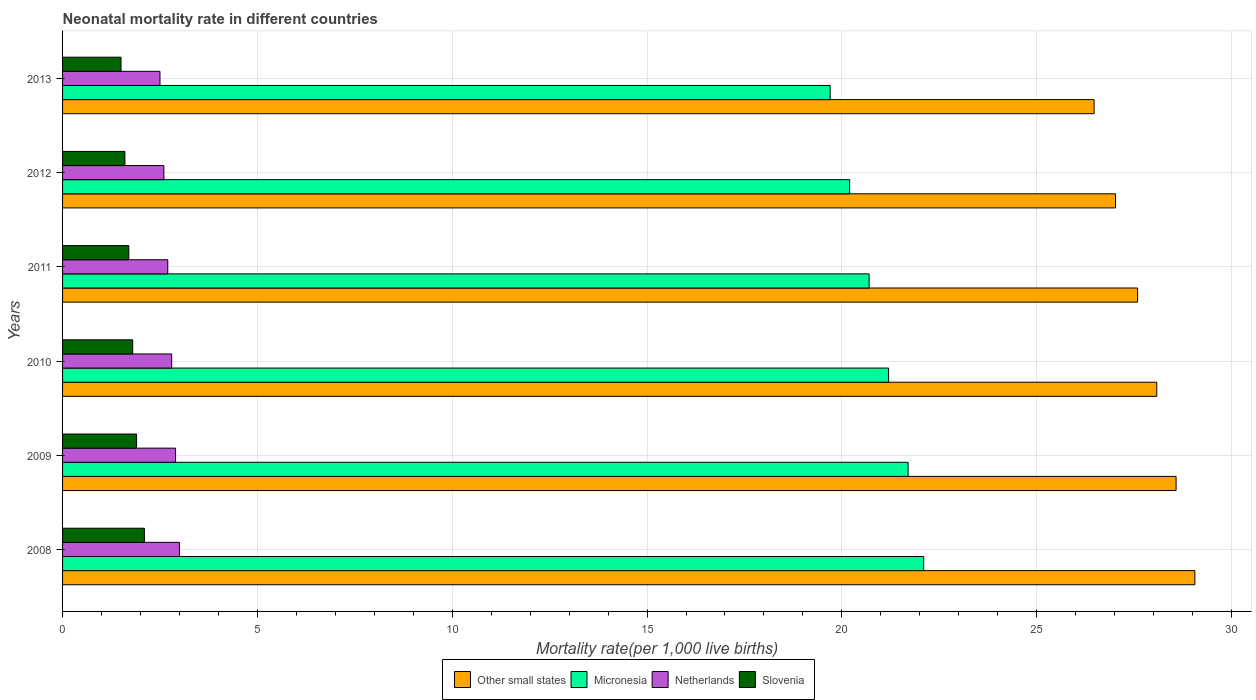How many different coloured bars are there?
Offer a very short reply. 4. Are the number of bars on each tick of the Y-axis equal?
Provide a succinct answer. Yes. In how many cases, is the number of bars for a given year not equal to the number of legend labels?
Give a very brief answer. 0. What is the neonatal mortality rate in Micronesia in 2009?
Your response must be concise. 21.7. Across all years, what is the minimum neonatal mortality rate in Netherlands?
Offer a very short reply. 2.5. In which year was the neonatal mortality rate in Slovenia maximum?
Your answer should be very brief. 2008. What is the difference between the neonatal mortality rate in Other small states in 2011 and the neonatal mortality rate in Slovenia in 2013?
Offer a terse response. 26.09. What is the average neonatal mortality rate in Slovenia per year?
Give a very brief answer. 1.77. In the year 2011, what is the difference between the neonatal mortality rate in Netherlands and neonatal mortality rate in Other small states?
Your response must be concise. -24.89. In how many years, is the neonatal mortality rate in Slovenia greater than 4 ?
Offer a terse response. 0. What is the ratio of the neonatal mortality rate in Other small states in 2008 to that in 2009?
Keep it short and to the point. 1.02. Is the neonatal mortality rate in Micronesia in 2009 less than that in 2010?
Ensure brevity in your answer.  No. Is the difference between the neonatal mortality rate in Netherlands in 2011 and 2013 greater than the difference between the neonatal mortality rate in Other small states in 2011 and 2013?
Ensure brevity in your answer.  No. What is the difference between the highest and the second highest neonatal mortality rate in Netherlands?
Give a very brief answer. 0.1. What is the difference between the highest and the lowest neonatal mortality rate in Slovenia?
Your response must be concise. 0.6. What does the 1st bar from the top in 2010 represents?
Give a very brief answer. Slovenia. What does the 1st bar from the bottom in 2013 represents?
Your answer should be compact. Other small states. How many bars are there?
Your answer should be very brief. 24. Are all the bars in the graph horizontal?
Your response must be concise. Yes. How many years are there in the graph?
Your response must be concise. 6. Does the graph contain grids?
Your answer should be compact. Yes. Where does the legend appear in the graph?
Provide a short and direct response. Bottom center. How are the legend labels stacked?
Your answer should be compact. Horizontal. What is the title of the graph?
Your answer should be compact. Neonatal mortality rate in different countries. Does "Monaco" appear as one of the legend labels in the graph?
Give a very brief answer. No. What is the label or title of the X-axis?
Make the answer very short. Mortality rate(per 1,0 live births). What is the label or title of the Y-axis?
Provide a succinct answer. Years. What is the Mortality rate(per 1,000 live births) of Other small states in 2008?
Provide a succinct answer. 29.06. What is the Mortality rate(per 1,000 live births) of Micronesia in 2008?
Ensure brevity in your answer.  22.1. What is the Mortality rate(per 1,000 live births) in Netherlands in 2008?
Your answer should be compact. 3. What is the Mortality rate(per 1,000 live births) of Slovenia in 2008?
Give a very brief answer. 2.1. What is the Mortality rate(per 1,000 live births) in Other small states in 2009?
Make the answer very short. 28.58. What is the Mortality rate(per 1,000 live births) in Micronesia in 2009?
Ensure brevity in your answer.  21.7. What is the Mortality rate(per 1,000 live births) in Netherlands in 2009?
Keep it short and to the point. 2.9. What is the Mortality rate(per 1,000 live births) of Slovenia in 2009?
Your response must be concise. 1.9. What is the Mortality rate(per 1,000 live births) in Other small states in 2010?
Your answer should be compact. 28.08. What is the Mortality rate(per 1,000 live births) in Micronesia in 2010?
Give a very brief answer. 21.2. What is the Mortality rate(per 1,000 live births) of Other small states in 2011?
Offer a terse response. 27.59. What is the Mortality rate(per 1,000 live births) in Micronesia in 2011?
Provide a short and direct response. 20.7. What is the Mortality rate(per 1,000 live births) in Netherlands in 2011?
Keep it short and to the point. 2.7. What is the Mortality rate(per 1,000 live births) in Other small states in 2012?
Make the answer very short. 27.02. What is the Mortality rate(per 1,000 live births) of Micronesia in 2012?
Make the answer very short. 20.2. What is the Mortality rate(per 1,000 live births) in Slovenia in 2012?
Make the answer very short. 1.6. What is the Mortality rate(per 1,000 live births) of Other small states in 2013?
Your answer should be very brief. 26.47. What is the Mortality rate(per 1,000 live births) of Micronesia in 2013?
Make the answer very short. 19.7. What is the Mortality rate(per 1,000 live births) in Slovenia in 2013?
Provide a short and direct response. 1.5. Across all years, what is the maximum Mortality rate(per 1,000 live births) of Other small states?
Provide a short and direct response. 29.06. Across all years, what is the maximum Mortality rate(per 1,000 live births) of Micronesia?
Offer a terse response. 22.1. Across all years, what is the maximum Mortality rate(per 1,000 live births) in Netherlands?
Keep it short and to the point. 3. Across all years, what is the minimum Mortality rate(per 1,000 live births) in Other small states?
Offer a terse response. 26.47. Across all years, what is the minimum Mortality rate(per 1,000 live births) in Micronesia?
Make the answer very short. 19.7. Across all years, what is the minimum Mortality rate(per 1,000 live births) in Netherlands?
Ensure brevity in your answer.  2.5. What is the total Mortality rate(per 1,000 live births) of Other small states in the graph?
Your response must be concise. 166.81. What is the total Mortality rate(per 1,000 live births) in Micronesia in the graph?
Provide a short and direct response. 125.6. What is the difference between the Mortality rate(per 1,000 live births) of Other small states in 2008 and that in 2009?
Make the answer very short. 0.48. What is the difference between the Mortality rate(per 1,000 live births) in Micronesia in 2008 and that in 2009?
Ensure brevity in your answer.  0.4. What is the difference between the Mortality rate(per 1,000 live births) of Netherlands in 2008 and that in 2009?
Your answer should be compact. 0.1. What is the difference between the Mortality rate(per 1,000 live births) of Other small states in 2008 and that in 2010?
Provide a succinct answer. 0.98. What is the difference between the Mortality rate(per 1,000 live births) of Slovenia in 2008 and that in 2010?
Provide a succinct answer. 0.3. What is the difference between the Mortality rate(per 1,000 live births) in Other small states in 2008 and that in 2011?
Offer a very short reply. 1.47. What is the difference between the Mortality rate(per 1,000 live births) in Netherlands in 2008 and that in 2011?
Your response must be concise. 0.3. What is the difference between the Mortality rate(per 1,000 live births) of Other small states in 2008 and that in 2012?
Your answer should be compact. 2.04. What is the difference between the Mortality rate(per 1,000 live births) in Netherlands in 2008 and that in 2012?
Make the answer very short. 0.4. What is the difference between the Mortality rate(per 1,000 live births) in Slovenia in 2008 and that in 2012?
Your response must be concise. 0.5. What is the difference between the Mortality rate(per 1,000 live births) of Other small states in 2008 and that in 2013?
Provide a succinct answer. 2.59. What is the difference between the Mortality rate(per 1,000 live births) of Micronesia in 2008 and that in 2013?
Offer a very short reply. 2.4. What is the difference between the Mortality rate(per 1,000 live births) in Other small states in 2009 and that in 2010?
Offer a very short reply. 0.5. What is the difference between the Mortality rate(per 1,000 live births) of Other small states in 2009 and that in 2011?
Your answer should be very brief. 0.99. What is the difference between the Mortality rate(per 1,000 live births) in Micronesia in 2009 and that in 2011?
Ensure brevity in your answer.  1. What is the difference between the Mortality rate(per 1,000 live births) in Slovenia in 2009 and that in 2011?
Your answer should be compact. 0.2. What is the difference between the Mortality rate(per 1,000 live births) in Other small states in 2009 and that in 2012?
Provide a short and direct response. 1.55. What is the difference between the Mortality rate(per 1,000 live births) of Micronesia in 2009 and that in 2012?
Make the answer very short. 1.5. What is the difference between the Mortality rate(per 1,000 live births) in Netherlands in 2009 and that in 2012?
Keep it short and to the point. 0.3. What is the difference between the Mortality rate(per 1,000 live births) of Slovenia in 2009 and that in 2012?
Your answer should be compact. 0.3. What is the difference between the Mortality rate(per 1,000 live births) in Other small states in 2009 and that in 2013?
Provide a short and direct response. 2.1. What is the difference between the Mortality rate(per 1,000 live births) of Slovenia in 2009 and that in 2013?
Give a very brief answer. 0.4. What is the difference between the Mortality rate(per 1,000 live births) of Other small states in 2010 and that in 2011?
Ensure brevity in your answer.  0.49. What is the difference between the Mortality rate(per 1,000 live births) in Micronesia in 2010 and that in 2011?
Provide a short and direct response. 0.5. What is the difference between the Mortality rate(per 1,000 live births) of Netherlands in 2010 and that in 2011?
Provide a succinct answer. 0.1. What is the difference between the Mortality rate(per 1,000 live births) of Slovenia in 2010 and that in 2011?
Your response must be concise. 0.1. What is the difference between the Mortality rate(per 1,000 live births) in Other small states in 2010 and that in 2012?
Your answer should be very brief. 1.06. What is the difference between the Mortality rate(per 1,000 live births) in Micronesia in 2010 and that in 2012?
Give a very brief answer. 1. What is the difference between the Mortality rate(per 1,000 live births) in Other small states in 2010 and that in 2013?
Your answer should be very brief. 1.61. What is the difference between the Mortality rate(per 1,000 live births) in Slovenia in 2010 and that in 2013?
Your answer should be compact. 0.3. What is the difference between the Mortality rate(per 1,000 live births) in Other small states in 2011 and that in 2012?
Your answer should be compact. 0.57. What is the difference between the Mortality rate(per 1,000 live births) of Micronesia in 2011 and that in 2012?
Your answer should be very brief. 0.5. What is the difference between the Mortality rate(per 1,000 live births) in Netherlands in 2011 and that in 2012?
Provide a succinct answer. 0.1. What is the difference between the Mortality rate(per 1,000 live births) in Slovenia in 2011 and that in 2012?
Your answer should be compact. 0.1. What is the difference between the Mortality rate(per 1,000 live births) in Other small states in 2011 and that in 2013?
Give a very brief answer. 1.12. What is the difference between the Mortality rate(per 1,000 live births) in Other small states in 2012 and that in 2013?
Give a very brief answer. 0.55. What is the difference between the Mortality rate(per 1,000 live births) in Netherlands in 2012 and that in 2013?
Your response must be concise. 0.1. What is the difference between the Mortality rate(per 1,000 live births) in Slovenia in 2012 and that in 2013?
Keep it short and to the point. 0.1. What is the difference between the Mortality rate(per 1,000 live births) of Other small states in 2008 and the Mortality rate(per 1,000 live births) of Micronesia in 2009?
Provide a short and direct response. 7.36. What is the difference between the Mortality rate(per 1,000 live births) in Other small states in 2008 and the Mortality rate(per 1,000 live births) in Netherlands in 2009?
Give a very brief answer. 26.16. What is the difference between the Mortality rate(per 1,000 live births) of Other small states in 2008 and the Mortality rate(per 1,000 live births) of Slovenia in 2009?
Provide a succinct answer. 27.16. What is the difference between the Mortality rate(per 1,000 live births) of Micronesia in 2008 and the Mortality rate(per 1,000 live births) of Slovenia in 2009?
Your response must be concise. 20.2. What is the difference between the Mortality rate(per 1,000 live births) of Other small states in 2008 and the Mortality rate(per 1,000 live births) of Micronesia in 2010?
Offer a very short reply. 7.86. What is the difference between the Mortality rate(per 1,000 live births) of Other small states in 2008 and the Mortality rate(per 1,000 live births) of Netherlands in 2010?
Ensure brevity in your answer.  26.26. What is the difference between the Mortality rate(per 1,000 live births) of Other small states in 2008 and the Mortality rate(per 1,000 live births) of Slovenia in 2010?
Offer a terse response. 27.26. What is the difference between the Mortality rate(per 1,000 live births) in Micronesia in 2008 and the Mortality rate(per 1,000 live births) in Netherlands in 2010?
Offer a terse response. 19.3. What is the difference between the Mortality rate(per 1,000 live births) of Micronesia in 2008 and the Mortality rate(per 1,000 live births) of Slovenia in 2010?
Provide a succinct answer. 20.3. What is the difference between the Mortality rate(per 1,000 live births) in Netherlands in 2008 and the Mortality rate(per 1,000 live births) in Slovenia in 2010?
Your answer should be compact. 1.2. What is the difference between the Mortality rate(per 1,000 live births) in Other small states in 2008 and the Mortality rate(per 1,000 live births) in Micronesia in 2011?
Ensure brevity in your answer.  8.36. What is the difference between the Mortality rate(per 1,000 live births) of Other small states in 2008 and the Mortality rate(per 1,000 live births) of Netherlands in 2011?
Your answer should be compact. 26.36. What is the difference between the Mortality rate(per 1,000 live births) of Other small states in 2008 and the Mortality rate(per 1,000 live births) of Slovenia in 2011?
Your answer should be very brief. 27.36. What is the difference between the Mortality rate(per 1,000 live births) in Micronesia in 2008 and the Mortality rate(per 1,000 live births) in Slovenia in 2011?
Your response must be concise. 20.4. What is the difference between the Mortality rate(per 1,000 live births) in Netherlands in 2008 and the Mortality rate(per 1,000 live births) in Slovenia in 2011?
Offer a terse response. 1.3. What is the difference between the Mortality rate(per 1,000 live births) in Other small states in 2008 and the Mortality rate(per 1,000 live births) in Micronesia in 2012?
Provide a succinct answer. 8.86. What is the difference between the Mortality rate(per 1,000 live births) in Other small states in 2008 and the Mortality rate(per 1,000 live births) in Netherlands in 2012?
Your answer should be compact. 26.46. What is the difference between the Mortality rate(per 1,000 live births) in Other small states in 2008 and the Mortality rate(per 1,000 live births) in Slovenia in 2012?
Your answer should be very brief. 27.46. What is the difference between the Mortality rate(per 1,000 live births) in Micronesia in 2008 and the Mortality rate(per 1,000 live births) in Netherlands in 2012?
Your response must be concise. 19.5. What is the difference between the Mortality rate(per 1,000 live births) in Other small states in 2008 and the Mortality rate(per 1,000 live births) in Micronesia in 2013?
Your response must be concise. 9.36. What is the difference between the Mortality rate(per 1,000 live births) in Other small states in 2008 and the Mortality rate(per 1,000 live births) in Netherlands in 2013?
Keep it short and to the point. 26.56. What is the difference between the Mortality rate(per 1,000 live births) of Other small states in 2008 and the Mortality rate(per 1,000 live births) of Slovenia in 2013?
Give a very brief answer. 27.56. What is the difference between the Mortality rate(per 1,000 live births) in Micronesia in 2008 and the Mortality rate(per 1,000 live births) in Netherlands in 2013?
Give a very brief answer. 19.6. What is the difference between the Mortality rate(per 1,000 live births) of Micronesia in 2008 and the Mortality rate(per 1,000 live births) of Slovenia in 2013?
Make the answer very short. 20.6. What is the difference between the Mortality rate(per 1,000 live births) of Other small states in 2009 and the Mortality rate(per 1,000 live births) of Micronesia in 2010?
Your answer should be compact. 7.38. What is the difference between the Mortality rate(per 1,000 live births) in Other small states in 2009 and the Mortality rate(per 1,000 live births) in Netherlands in 2010?
Your response must be concise. 25.78. What is the difference between the Mortality rate(per 1,000 live births) in Other small states in 2009 and the Mortality rate(per 1,000 live births) in Slovenia in 2010?
Provide a succinct answer. 26.78. What is the difference between the Mortality rate(per 1,000 live births) of Other small states in 2009 and the Mortality rate(per 1,000 live births) of Micronesia in 2011?
Your response must be concise. 7.88. What is the difference between the Mortality rate(per 1,000 live births) in Other small states in 2009 and the Mortality rate(per 1,000 live births) in Netherlands in 2011?
Keep it short and to the point. 25.88. What is the difference between the Mortality rate(per 1,000 live births) in Other small states in 2009 and the Mortality rate(per 1,000 live births) in Slovenia in 2011?
Provide a succinct answer. 26.88. What is the difference between the Mortality rate(per 1,000 live births) of Micronesia in 2009 and the Mortality rate(per 1,000 live births) of Slovenia in 2011?
Keep it short and to the point. 20. What is the difference between the Mortality rate(per 1,000 live births) of Other small states in 2009 and the Mortality rate(per 1,000 live births) of Micronesia in 2012?
Make the answer very short. 8.38. What is the difference between the Mortality rate(per 1,000 live births) in Other small states in 2009 and the Mortality rate(per 1,000 live births) in Netherlands in 2012?
Give a very brief answer. 25.98. What is the difference between the Mortality rate(per 1,000 live births) in Other small states in 2009 and the Mortality rate(per 1,000 live births) in Slovenia in 2012?
Provide a short and direct response. 26.98. What is the difference between the Mortality rate(per 1,000 live births) of Micronesia in 2009 and the Mortality rate(per 1,000 live births) of Slovenia in 2012?
Give a very brief answer. 20.1. What is the difference between the Mortality rate(per 1,000 live births) in Netherlands in 2009 and the Mortality rate(per 1,000 live births) in Slovenia in 2012?
Your answer should be very brief. 1.3. What is the difference between the Mortality rate(per 1,000 live births) in Other small states in 2009 and the Mortality rate(per 1,000 live births) in Micronesia in 2013?
Offer a terse response. 8.88. What is the difference between the Mortality rate(per 1,000 live births) in Other small states in 2009 and the Mortality rate(per 1,000 live births) in Netherlands in 2013?
Provide a succinct answer. 26.08. What is the difference between the Mortality rate(per 1,000 live births) of Other small states in 2009 and the Mortality rate(per 1,000 live births) of Slovenia in 2013?
Provide a short and direct response. 27.08. What is the difference between the Mortality rate(per 1,000 live births) of Micronesia in 2009 and the Mortality rate(per 1,000 live births) of Netherlands in 2013?
Your answer should be compact. 19.2. What is the difference between the Mortality rate(per 1,000 live births) in Micronesia in 2009 and the Mortality rate(per 1,000 live births) in Slovenia in 2013?
Provide a succinct answer. 20.2. What is the difference between the Mortality rate(per 1,000 live births) of Netherlands in 2009 and the Mortality rate(per 1,000 live births) of Slovenia in 2013?
Your answer should be very brief. 1.4. What is the difference between the Mortality rate(per 1,000 live births) in Other small states in 2010 and the Mortality rate(per 1,000 live births) in Micronesia in 2011?
Give a very brief answer. 7.38. What is the difference between the Mortality rate(per 1,000 live births) of Other small states in 2010 and the Mortality rate(per 1,000 live births) of Netherlands in 2011?
Offer a very short reply. 25.38. What is the difference between the Mortality rate(per 1,000 live births) of Other small states in 2010 and the Mortality rate(per 1,000 live births) of Slovenia in 2011?
Offer a terse response. 26.38. What is the difference between the Mortality rate(per 1,000 live births) in Micronesia in 2010 and the Mortality rate(per 1,000 live births) in Slovenia in 2011?
Provide a succinct answer. 19.5. What is the difference between the Mortality rate(per 1,000 live births) in Netherlands in 2010 and the Mortality rate(per 1,000 live births) in Slovenia in 2011?
Provide a succinct answer. 1.1. What is the difference between the Mortality rate(per 1,000 live births) in Other small states in 2010 and the Mortality rate(per 1,000 live births) in Micronesia in 2012?
Your response must be concise. 7.88. What is the difference between the Mortality rate(per 1,000 live births) in Other small states in 2010 and the Mortality rate(per 1,000 live births) in Netherlands in 2012?
Make the answer very short. 25.48. What is the difference between the Mortality rate(per 1,000 live births) in Other small states in 2010 and the Mortality rate(per 1,000 live births) in Slovenia in 2012?
Ensure brevity in your answer.  26.48. What is the difference between the Mortality rate(per 1,000 live births) in Micronesia in 2010 and the Mortality rate(per 1,000 live births) in Netherlands in 2012?
Your answer should be very brief. 18.6. What is the difference between the Mortality rate(per 1,000 live births) of Micronesia in 2010 and the Mortality rate(per 1,000 live births) of Slovenia in 2012?
Provide a short and direct response. 19.6. What is the difference between the Mortality rate(per 1,000 live births) of Netherlands in 2010 and the Mortality rate(per 1,000 live births) of Slovenia in 2012?
Keep it short and to the point. 1.2. What is the difference between the Mortality rate(per 1,000 live births) in Other small states in 2010 and the Mortality rate(per 1,000 live births) in Micronesia in 2013?
Keep it short and to the point. 8.38. What is the difference between the Mortality rate(per 1,000 live births) in Other small states in 2010 and the Mortality rate(per 1,000 live births) in Netherlands in 2013?
Make the answer very short. 25.58. What is the difference between the Mortality rate(per 1,000 live births) in Other small states in 2010 and the Mortality rate(per 1,000 live births) in Slovenia in 2013?
Keep it short and to the point. 26.58. What is the difference between the Mortality rate(per 1,000 live births) in Netherlands in 2010 and the Mortality rate(per 1,000 live births) in Slovenia in 2013?
Ensure brevity in your answer.  1.3. What is the difference between the Mortality rate(per 1,000 live births) in Other small states in 2011 and the Mortality rate(per 1,000 live births) in Micronesia in 2012?
Provide a succinct answer. 7.39. What is the difference between the Mortality rate(per 1,000 live births) of Other small states in 2011 and the Mortality rate(per 1,000 live births) of Netherlands in 2012?
Your answer should be compact. 24.99. What is the difference between the Mortality rate(per 1,000 live births) in Other small states in 2011 and the Mortality rate(per 1,000 live births) in Slovenia in 2012?
Ensure brevity in your answer.  25.99. What is the difference between the Mortality rate(per 1,000 live births) in Micronesia in 2011 and the Mortality rate(per 1,000 live births) in Netherlands in 2012?
Ensure brevity in your answer.  18.1. What is the difference between the Mortality rate(per 1,000 live births) in Netherlands in 2011 and the Mortality rate(per 1,000 live births) in Slovenia in 2012?
Provide a succinct answer. 1.1. What is the difference between the Mortality rate(per 1,000 live births) of Other small states in 2011 and the Mortality rate(per 1,000 live births) of Micronesia in 2013?
Give a very brief answer. 7.89. What is the difference between the Mortality rate(per 1,000 live births) of Other small states in 2011 and the Mortality rate(per 1,000 live births) of Netherlands in 2013?
Offer a very short reply. 25.09. What is the difference between the Mortality rate(per 1,000 live births) of Other small states in 2011 and the Mortality rate(per 1,000 live births) of Slovenia in 2013?
Your answer should be very brief. 26.09. What is the difference between the Mortality rate(per 1,000 live births) in Micronesia in 2011 and the Mortality rate(per 1,000 live births) in Slovenia in 2013?
Your response must be concise. 19.2. What is the difference between the Mortality rate(per 1,000 live births) in Netherlands in 2011 and the Mortality rate(per 1,000 live births) in Slovenia in 2013?
Provide a short and direct response. 1.2. What is the difference between the Mortality rate(per 1,000 live births) of Other small states in 2012 and the Mortality rate(per 1,000 live births) of Micronesia in 2013?
Your answer should be compact. 7.32. What is the difference between the Mortality rate(per 1,000 live births) in Other small states in 2012 and the Mortality rate(per 1,000 live births) in Netherlands in 2013?
Make the answer very short. 24.52. What is the difference between the Mortality rate(per 1,000 live births) in Other small states in 2012 and the Mortality rate(per 1,000 live births) in Slovenia in 2013?
Keep it short and to the point. 25.52. What is the difference between the Mortality rate(per 1,000 live births) of Micronesia in 2012 and the Mortality rate(per 1,000 live births) of Netherlands in 2013?
Your response must be concise. 17.7. What is the difference between the Mortality rate(per 1,000 live births) of Micronesia in 2012 and the Mortality rate(per 1,000 live births) of Slovenia in 2013?
Your answer should be compact. 18.7. What is the difference between the Mortality rate(per 1,000 live births) of Netherlands in 2012 and the Mortality rate(per 1,000 live births) of Slovenia in 2013?
Provide a succinct answer. 1.1. What is the average Mortality rate(per 1,000 live births) of Other small states per year?
Offer a very short reply. 27.8. What is the average Mortality rate(per 1,000 live births) in Micronesia per year?
Provide a succinct answer. 20.93. What is the average Mortality rate(per 1,000 live births) in Netherlands per year?
Keep it short and to the point. 2.75. What is the average Mortality rate(per 1,000 live births) of Slovenia per year?
Your answer should be very brief. 1.77. In the year 2008, what is the difference between the Mortality rate(per 1,000 live births) of Other small states and Mortality rate(per 1,000 live births) of Micronesia?
Your response must be concise. 6.96. In the year 2008, what is the difference between the Mortality rate(per 1,000 live births) of Other small states and Mortality rate(per 1,000 live births) of Netherlands?
Make the answer very short. 26.06. In the year 2008, what is the difference between the Mortality rate(per 1,000 live births) in Other small states and Mortality rate(per 1,000 live births) in Slovenia?
Provide a short and direct response. 26.96. In the year 2008, what is the difference between the Mortality rate(per 1,000 live births) of Micronesia and Mortality rate(per 1,000 live births) of Netherlands?
Ensure brevity in your answer.  19.1. In the year 2008, what is the difference between the Mortality rate(per 1,000 live births) of Micronesia and Mortality rate(per 1,000 live births) of Slovenia?
Provide a short and direct response. 20. In the year 2008, what is the difference between the Mortality rate(per 1,000 live births) of Netherlands and Mortality rate(per 1,000 live births) of Slovenia?
Make the answer very short. 0.9. In the year 2009, what is the difference between the Mortality rate(per 1,000 live births) in Other small states and Mortality rate(per 1,000 live births) in Micronesia?
Ensure brevity in your answer.  6.88. In the year 2009, what is the difference between the Mortality rate(per 1,000 live births) of Other small states and Mortality rate(per 1,000 live births) of Netherlands?
Offer a very short reply. 25.68. In the year 2009, what is the difference between the Mortality rate(per 1,000 live births) in Other small states and Mortality rate(per 1,000 live births) in Slovenia?
Your answer should be very brief. 26.68. In the year 2009, what is the difference between the Mortality rate(per 1,000 live births) in Micronesia and Mortality rate(per 1,000 live births) in Slovenia?
Ensure brevity in your answer.  19.8. In the year 2009, what is the difference between the Mortality rate(per 1,000 live births) of Netherlands and Mortality rate(per 1,000 live births) of Slovenia?
Your answer should be compact. 1. In the year 2010, what is the difference between the Mortality rate(per 1,000 live births) of Other small states and Mortality rate(per 1,000 live births) of Micronesia?
Offer a very short reply. 6.88. In the year 2010, what is the difference between the Mortality rate(per 1,000 live births) of Other small states and Mortality rate(per 1,000 live births) of Netherlands?
Keep it short and to the point. 25.28. In the year 2010, what is the difference between the Mortality rate(per 1,000 live births) of Other small states and Mortality rate(per 1,000 live births) of Slovenia?
Your answer should be very brief. 26.28. In the year 2010, what is the difference between the Mortality rate(per 1,000 live births) in Micronesia and Mortality rate(per 1,000 live births) in Slovenia?
Provide a short and direct response. 19.4. In the year 2010, what is the difference between the Mortality rate(per 1,000 live births) in Netherlands and Mortality rate(per 1,000 live births) in Slovenia?
Offer a terse response. 1. In the year 2011, what is the difference between the Mortality rate(per 1,000 live births) in Other small states and Mortality rate(per 1,000 live births) in Micronesia?
Ensure brevity in your answer.  6.89. In the year 2011, what is the difference between the Mortality rate(per 1,000 live births) in Other small states and Mortality rate(per 1,000 live births) in Netherlands?
Your answer should be compact. 24.89. In the year 2011, what is the difference between the Mortality rate(per 1,000 live births) in Other small states and Mortality rate(per 1,000 live births) in Slovenia?
Provide a succinct answer. 25.89. In the year 2011, what is the difference between the Mortality rate(per 1,000 live births) in Micronesia and Mortality rate(per 1,000 live births) in Netherlands?
Ensure brevity in your answer.  18. In the year 2011, what is the difference between the Mortality rate(per 1,000 live births) in Micronesia and Mortality rate(per 1,000 live births) in Slovenia?
Keep it short and to the point. 19. In the year 2012, what is the difference between the Mortality rate(per 1,000 live births) of Other small states and Mortality rate(per 1,000 live births) of Micronesia?
Provide a short and direct response. 6.82. In the year 2012, what is the difference between the Mortality rate(per 1,000 live births) in Other small states and Mortality rate(per 1,000 live births) in Netherlands?
Keep it short and to the point. 24.42. In the year 2012, what is the difference between the Mortality rate(per 1,000 live births) in Other small states and Mortality rate(per 1,000 live births) in Slovenia?
Ensure brevity in your answer.  25.42. In the year 2013, what is the difference between the Mortality rate(per 1,000 live births) of Other small states and Mortality rate(per 1,000 live births) of Micronesia?
Offer a very short reply. 6.77. In the year 2013, what is the difference between the Mortality rate(per 1,000 live births) of Other small states and Mortality rate(per 1,000 live births) of Netherlands?
Your answer should be compact. 23.97. In the year 2013, what is the difference between the Mortality rate(per 1,000 live births) in Other small states and Mortality rate(per 1,000 live births) in Slovenia?
Offer a very short reply. 24.97. In the year 2013, what is the difference between the Mortality rate(per 1,000 live births) of Micronesia and Mortality rate(per 1,000 live births) of Netherlands?
Give a very brief answer. 17.2. In the year 2013, what is the difference between the Mortality rate(per 1,000 live births) in Netherlands and Mortality rate(per 1,000 live births) in Slovenia?
Keep it short and to the point. 1. What is the ratio of the Mortality rate(per 1,000 live births) of Other small states in 2008 to that in 2009?
Make the answer very short. 1.02. What is the ratio of the Mortality rate(per 1,000 live births) of Micronesia in 2008 to that in 2009?
Ensure brevity in your answer.  1.02. What is the ratio of the Mortality rate(per 1,000 live births) of Netherlands in 2008 to that in 2009?
Your response must be concise. 1.03. What is the ratio of the Mortality rate(per 1,000 live births) of Slovenia in 2008 to that in 2009?
Ensure brevity in your answer.  1.11. What is the ratio of the Mortality rate(per 1,000 live births) in Other small states in 2008 to that in 2010?
Give a very brief answer. 1.03. What is the ratio of the Mortality rate(per 1,000 live births) of Micronesia in 2008 to that in 2010?
Keep it short and to the point. 1.04. What is the ratio of the Mortality rate(per 1,000 live births) in Netherlands in 2008 to that in 2010?
Provide a succinct answer. 1.07. What is the ratio of the Mortality rate(per 1,000 live births) of Other small states in 2008 to that in 2011?
Give a very brief answer. 1.05. What is the ratio of the Mortality rate(per 1,000 live births) in Micronesia in 2008 to that in 2011?
Provide a succinct answer. 1.07. What is the ratio of the Mortality rate(per 1,000 live births) in Netherlands in 2008 to that in 2011?
Your answer should be compact. 1.11. What is the ratio of the Mortality rate(per 1,000 live births) of Slovenia in 2008 to that in 2011?
Your answer should be compact. 1.24. What is the ratio of the Mortality rate(per 1,000 live births) of Other small states in 2008 to that in 2012?
Ensure brevity in your answer.  1.08. What is the ratio of the Mortality rate(per 1,000 live births) in Micronesia in 2008 to that in 2012?
Provide a short and direct response. 1.09. What is the ratio of the Mortality rate(per 1,000 live births) in Netherlands in 2008 to that in 2012?
Provide a short and direct response. 1.15. What is the ratio of the Mortality rate(per 1,000 live births) of Slovenia in 2008 to that in 2012?
Ensure brevity in your answer.  1.31. What is the ratio of the Mortality rate(per 1,000 live births) in Other small states in 2008 to that in 2013?
Make the answer very short. 1.1. What is the ratio of the Mortality rate(per 1,000 live births) in Micronesia in 2008 to that in 2013?
Keep it short and to the point. 1.12. What is the ratio of the Mortality rate(per 1,000 live births) of Slovenia in 2008 to that in 2013?
Your response must be concise. 1.4. What is the ratio of the Mortality rate(per 1,000 live births) of Other small states in 2009 to that in 2010?
Your response must be concise. 1.02. What is the ratio of the Mortality rate(per 1,000 live births) in Micronesia in 2009 to that in 2010?
Ensure brevity in your answer.  1.02. What is the ratio of the Mortality rate(per 1,000 live births) in Netherlands in 2009 to that in 2010?
Ensure brevity in your answer.  1.04. What is the ratio of the Mortality rate(per 1,000 live births) of Slovenia in 2009 to that in 2010?
Offer a very short reply. 1.06. What is the ratio of the Mortality rate(per 1,000 live births) of Other small states in 2009 to that in 2011?
Your answer should be compact. 1.04. What is the ratio of the Mortality rate(per 1,000 live births) in Micronesia in 2009 to that in 2011?
Make the answer very short. 1.05. What is the ratio of the Mortality rate(per 1,000 live births) in Netherlands in 2009 to that in 2011?
Ensure brevity in your answer.  1.07. What is the ratio of the Mortality rate(per 1,000 live births) in Slovenia in 2009 to that in 2011?
Your answer should be compact. 1.12. What is the ratio of the Mortality rate(per 1,000 live births) in Other small states in 2009 to that in 2012?
Provide a succinct answer. 1.06. What is the ratio of the Mortality rate(per 1,000 live births) in Micronesia in 2009 to that in 2012?
Offer a terse response. 1.07. What is the ratio of the Mortality rate(per 1,000 live births) of Netherlands in 2009 to that in 2012?
Keep it short and to the point. 1.12. What is the ratio of the Mortality rate(per 1,000 live births) of Slovenia in 2009 to that in 2012?
Keep it short and to the point. 1.19. What is the ratio of the Mortality rate(per 1,000 live births) of Other small states in 2009 to that in 2013?
Make the answer very short. 1.08. What is the ratio of the Mortality rate(per 1,000 live births) in Micronesia in 2009 to that in 2013?
Make the answer very short. 1.1. What is the ratio of the Mortality rate(per 1,000 live births) of Netherlands in 2009 to that in 2013?
Keep it short and to the point. 1.16. What is the ratio of the Mortality rate(per 1,000 live births) of Slovenia in 2009 to that in 2013?
Give a very brief answer. 1.27. What is the ratio of the Mortality rate(per 1,000 live births) of Other small states in 2010 to that in 2011?
Provide a short and direct response. 1.02. What is the ratio of the Mortality rate(per 1,000 live births) in Micronesia in 2010 to that in 2011?
Provide a short and direct response. 1.02. What is the ratio of the Mortality rate(per 1,000 live births) in Slovenia in 2010 to that in 2011?
Ensure brevity in your answer.  1.06. What is the ratio of the Mortality rate(per 1,000 live births) in Other small states in 2010 to that in 2012?
Offer a terse response. 1.04. What is the ratio of the Mortality rate(per 1,000 live births) of Micronesia in 2010 to that in 2012?
Your response must be concise. 1.05. What is the ratio of the Mortality rate(per 1,000 live births) in Netherlands in 2010 to that in 2012?
Give a very brief answer. 1.08. What is the ratio of the Mortality rate(per 1,000 live births) of Other small states in 2010 to that in 2013?
Offer a terse response. 1.06. What is the ratio of the Mortality rate(per 1,000 live births) in Micronesia in 2010 to that in 2013?
Offer a terse response. 1.08. What is the ratio of the Mortality rate(per 1,000 live births) of Netherlands in 2010 to that in 2013?
Provide a short and direct response. 1.12. What is the ratio of the Mortality rate(per 1,000 live births) in Slovenia in 2010 to that in 2013?
Offer a terse response. 1.2. What is the ratio of the Mortality rate(per 1,000 live births) of Other small states in 2011 to that in 2012?
Ensure brevity in your answer.  1.02. What is the ratio of the Mortality rate(per 1,000 live births) in Micronesia in 2011 to that in 2012?
Offer a terse response. 1.02. What is the ratio of the Mortality rate(per 1,000 live births) of Other small states in 2011 to that in 2013?
Keep it short and to the point. 1.04. What is the ratio of the Mortality rate(per 1,000 live births) of Micronesia in 2011 to that in 2013?
Offer a very short reply. 1.05. What is the ratio of the Mortality rate(per 1,000 live births) of Slovenia in 2011 to that in 2013?
Your answer should be compact. 1.13. What is the ratio of the Mortality rate(per 1,000 live births) in Other small states in 2012 to that in 2013?
Ensure brevity in your answer.  1.02. What is the ratio of the Mortality rate(per 1,000 live births) of Micronesia in 2012 to that in 2013?
Your answer should be very brief. 1.03. What is the ratio of the Mortality rate(per 1,000 live births) of Netherlands in 2012 to that in 2013?
Your answer should be compact. 1.04. What is the ratio of the Mortality rate(per 1,000 live births) in Slovenia in 2012 to that in 2013?
Make the answer very short. 1.07. What is the difference between the highest and the second highest Mortality rate(per 1,000 live births) in Other small states?
Provide a succinct answer. 0.48. What is the difference between the highest and the second highest Mortality rate(per 1,000 live births) in Micronesia?
Your response must be concise. 0.4. What is the difference between the highest and the second highest Mortality rate(per 1,000 live births) of Netherlands?
Provide a succinct answer. 0.1. What is the difference between the highest and the second highest Mortality rate(per 1,000 live births) in Slovenia?
Your response must be concise. 0.2. What is the difference between the highest and the lowest Mortality rate(per 1,000 live births) of Other small states?
Give a very brief answer. 2.59. What is the difference between the highest and the lowest Mortality rate(per 1,000 live births) of Slovenia?
Offer a very short reply. 0.6. 